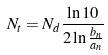<formula> <loc_0><loc_0><loc_500><loc_500>N _ { t } = N _ { d } \frac { \ln 1 0 } { 2 \ln \frac { b _ { n } } { a _ { n } } }</formula> 